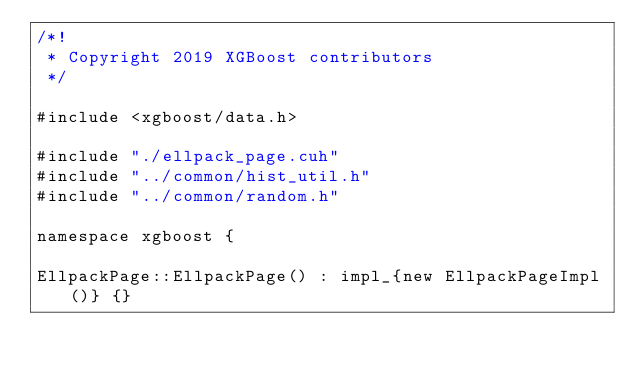Convert code to text. <code><loc_0><loc_0><loc_500><loc_500><_Cuda_>/*!
 * Copyright 2019 XGBoost contributors
 */

#include <xgboost/data.h>

#include "./ellpack_page.cuh"
#include "../common/hist_util.h"
#include "../common/random.h"

namespace xgboost {

EllpackPage::EllpackPage() : impl_{new EllpackPageImpl()} {}
</code> 